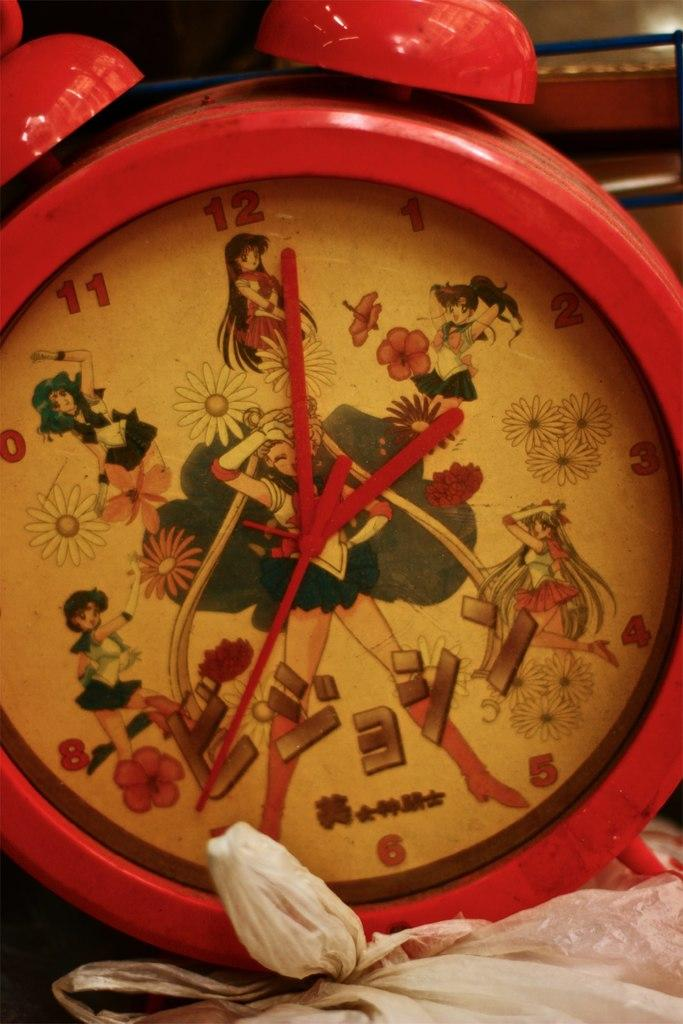Provide a one-sentence caption for the provided image. An alarm clock features a cartoon woman whose feet stand on either side of the number 6. 